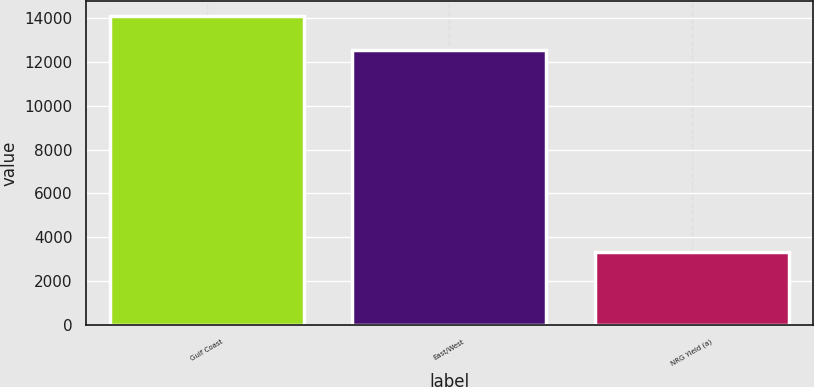Convert chart to OTSL. <chart><loc_0><loc_0><loc_500><loc_500><bar_chart><fcel>Gulf Coast<fcel>East/West<fcel>NRG Yield (a)<nl><fcel>14085<fcel>12519<fcel>3310<nl></chart> 